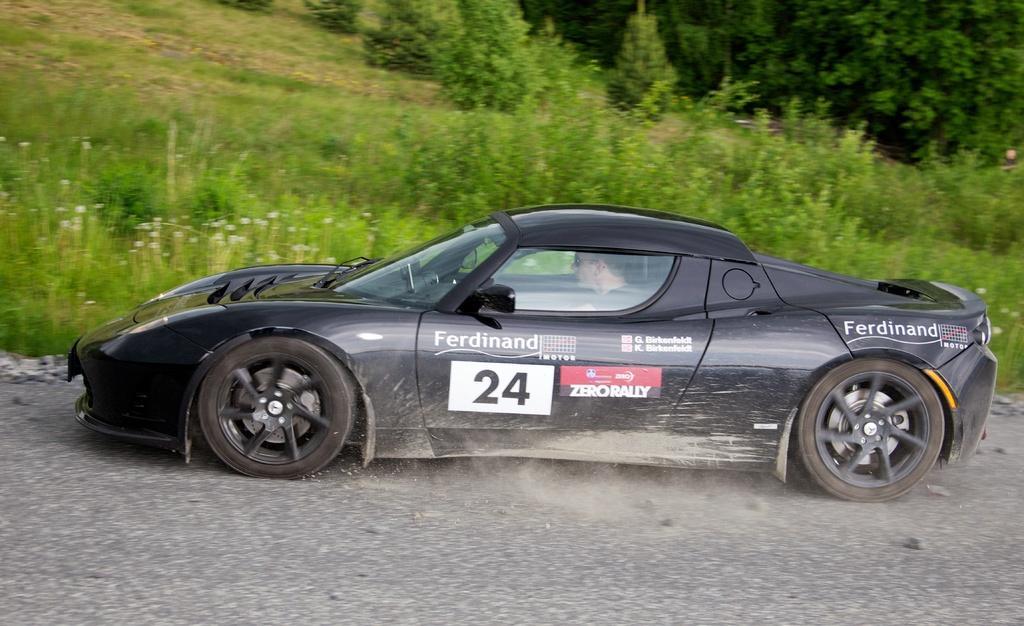Describe this image in one or two sentences. This picture is clicked outside. In the center there is a person riding a black color car. In the background we can see the plants, grass and the trees. 